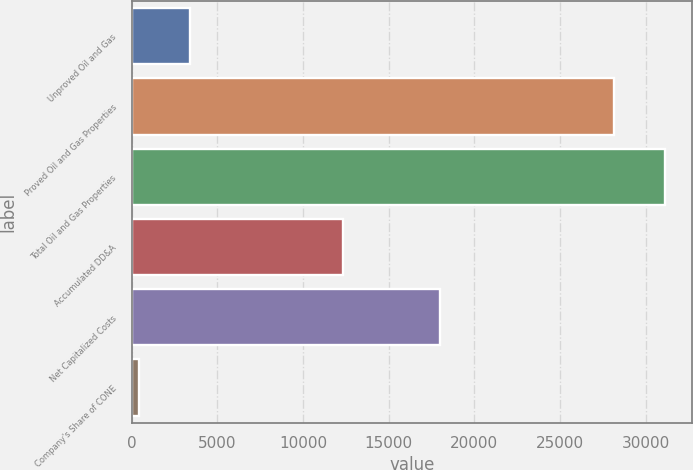Convert chart. <chart><loc_0><loc_0><loc_500><loc_500><bar_chart><fcel>Unproved Oil and Gas<fcel>Proved Oil and Gas Properties<fcel>Total Oil and Gas Properties<fcel>Accumulated DD&A<fcel>Net Capitalized Costs<fcel>Company's Share of CONE<nl><fcel>3431.5<fcel>28158<fcel>31149.5<fcel>12325<fcel>18030<fcel>440<nl></chart> 